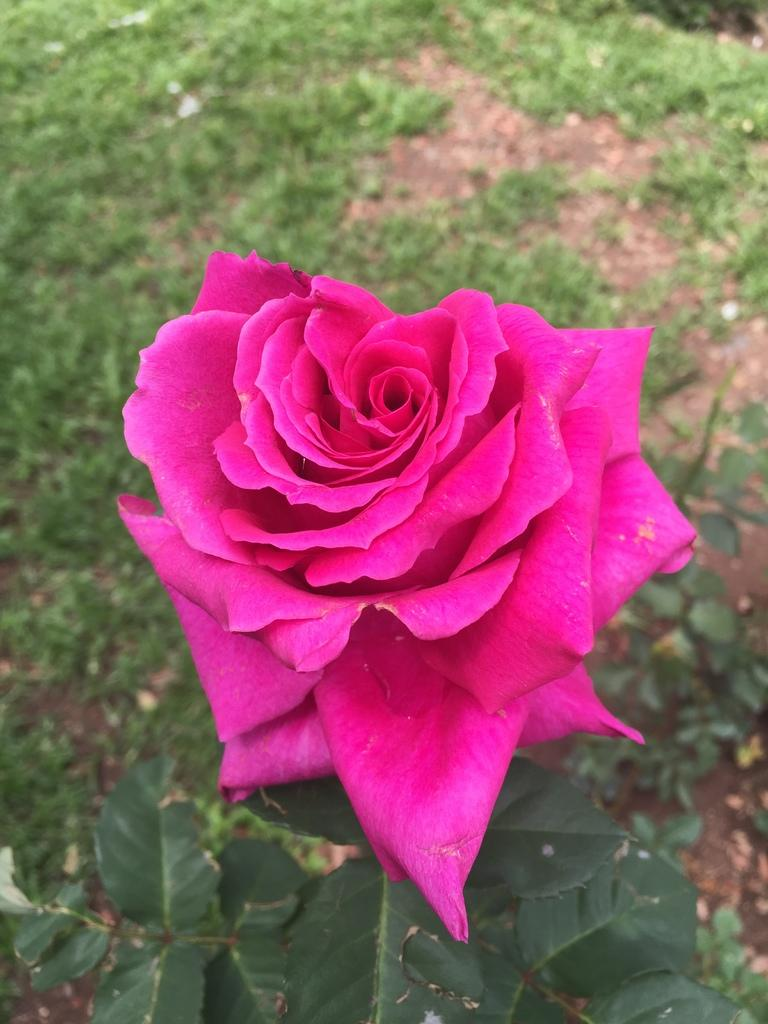What type of flower is on the plant in the image? There is a red rose on a plant in the image. What type of vegetation is visible in the image? Green grass is visible in the image. What else can be seen on the plant besides the red rose? Leaves are present in the image. What type of pickle is being held by the rose in the image? There is no pickle present in the image; it features a red rose on a plant with leaves and green grass. 